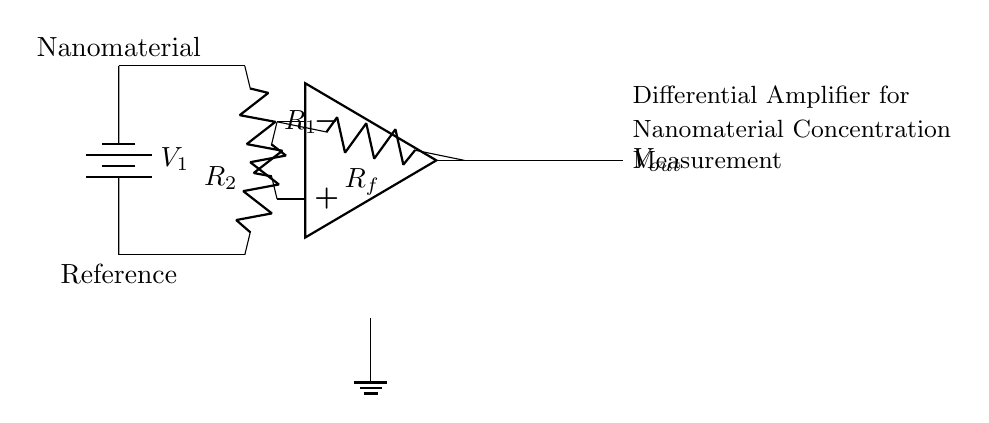what type of amplifier is used in this circuit? The circuit diagram shows a differential amplifier, characterized by its two input voltages and ability to amplify the difference between them.
Answer: differential amplifier what are the resistances in this circuit? The circuit features three resistors: R1 and R2 are the input resistors, and Rf is the feedback resistor, which sets the gain of the amplifier.
Answer: R1, R2, Rf what do the voltage sources represent? The voltage sources V1 and the reference voltage provide the voltage inputs necessary for measuring the concentration of the nanomaterial against a baseline/reference.
Answer: nanomaterial and reference how does the output voltage relate to the input voltages? The output voltage, Vout, is determined by the difference between the input voltages V1 and the reference voltage, modified by the gain set by the resistors.
Answer: difference amplified by gain what is the function of the feedback resistor in this circuit? The feedback resistor Rf is crucial as it establishes the gain of the amplifier, influencing how much the output voltage changes in response to the difference of the input voltages.
Answer: sets gain how do R1 and R2 contribute to the measurement accuracy? Resistors R1 and R2 determine the input impedance and the scaling of the differential signal; proper values help optimize accuracy and minimize error in measuring the nanomaterial concentration.
Answer: optimize accuracy what happens to the output voltage if the input voltages are equal? If the input voltages (V1 and the reference) are equal, the output voltage Vout will be zero since the amplifier only responds to the difference between its inputs.
Answer: zero 